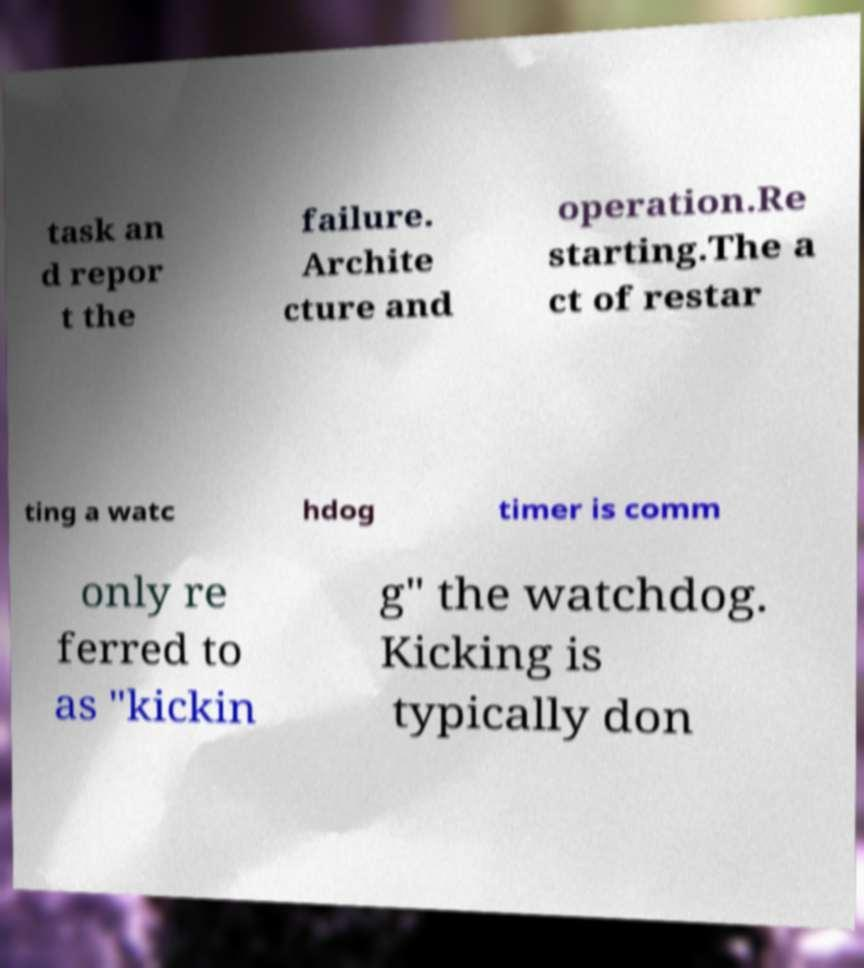Can you read and provide the text displayed in the image?This photo seems to have some interesting text. Can you extract and type it out for me? task an d repor t the failure. Archite cture and operation.Re starting.The a ct of restar ting a watc hdog timer is comm only re ferred to as "kickin g" the watchdog. Kicking is typically don 